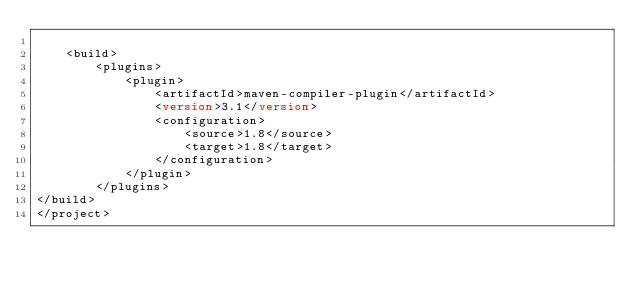Convert code to text. <code><loc_0><loc_0><loc_500><loc_500><_XML_>  
	<build>
		<plugins>
			<plugin>
				<artifactId>maven-compiler-plugin</artifactId>
				<version>3.1</version>
				<configuration>
					<source>1.8</source>
					<target>1.8</target>
				</configuration>
			</plugin>
		</plugins>
</build>
</project></code> 